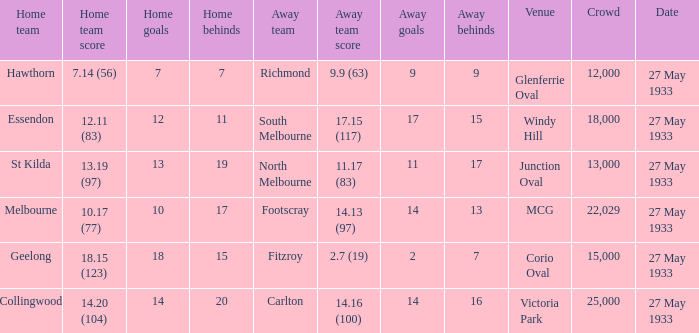In the match where the home team scored 14.20 (104), how many attendees were in the crowd? 25000.0. 